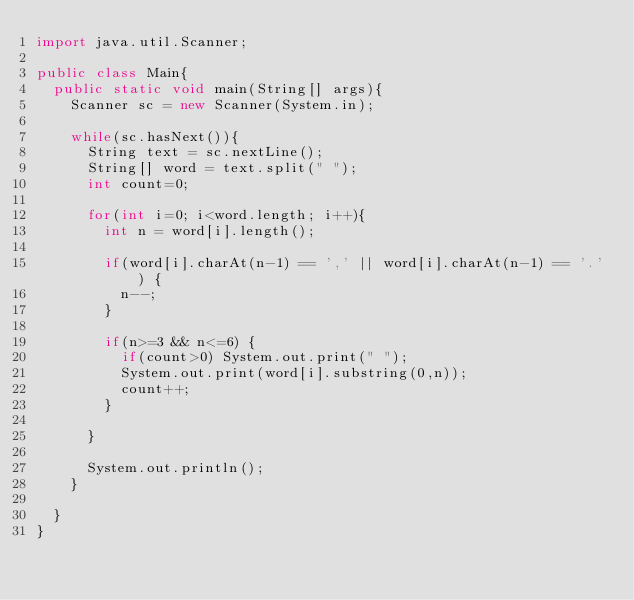<code> <loc_0><loc_0><loc_500><loc_500><_Java_>import java.util.Scanner;

public class Main{
	public static void main(String[] args){
		Scanner sc = new Scanner(System.in);
		
		while(sc.hasNext()){
			String text = sc.nextLine();
			String[] word = text.split(" ");
			int count=0;
			
			for(int i=0; i<word.length; i++){		
				int n = word[i].length();
						
				if(word[i].charAt(n-1) == ',' || word[i].charAt(n-1) == '.') {
					n--;
				}
		
				if(n>=3 && n<=6) {
					if(count>0) System.out.print(" ");
					System.out.print(word[i].substring(0,n));
					count++;
				}
				
			}
			
			System.out.println();
		}
	
	}
}</code> 